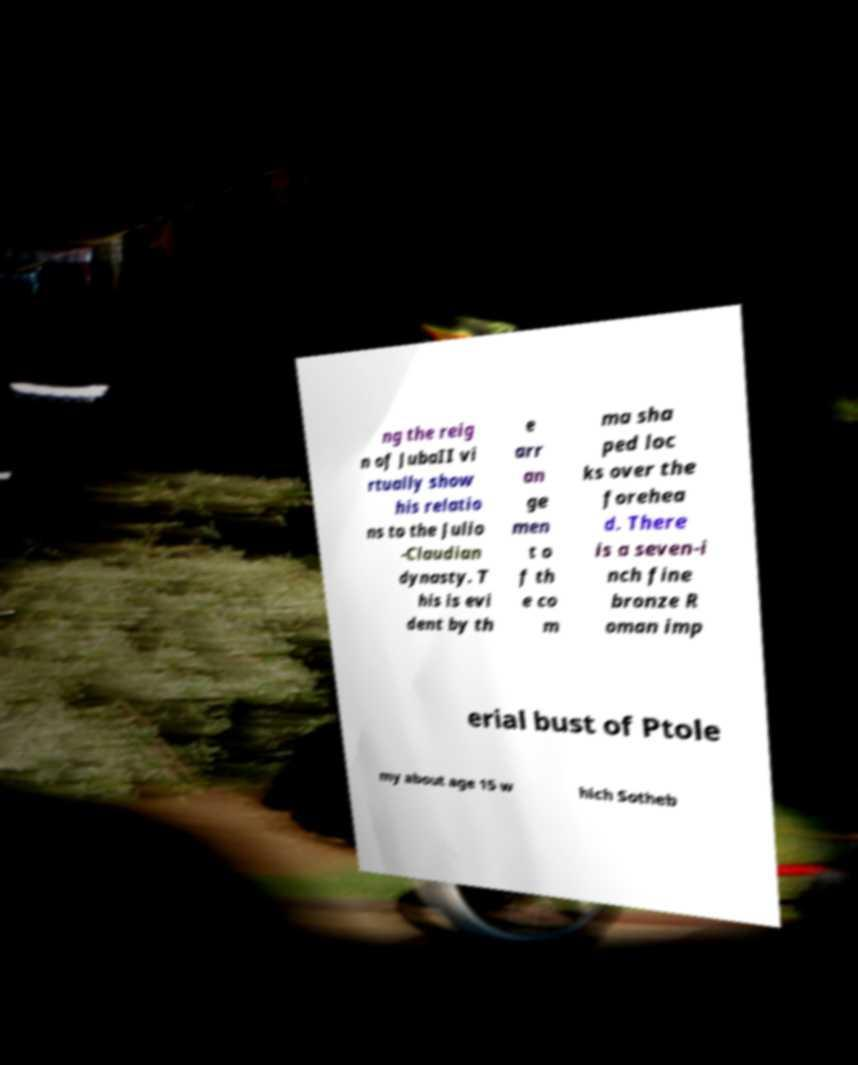Can you accurately transcribe the text from the provided image for me? ng the reig n of JubaII vi rtually show his relatio ns to the Julio -Claudian dynasty. T his is evi dent by th e arr an ge men t o f th e co m ma sha ped loc ks over the forehea d. There is a seven-i nch fine bronze R oman imp erial bust of Ptole my about age 15 w hich Sotheb 